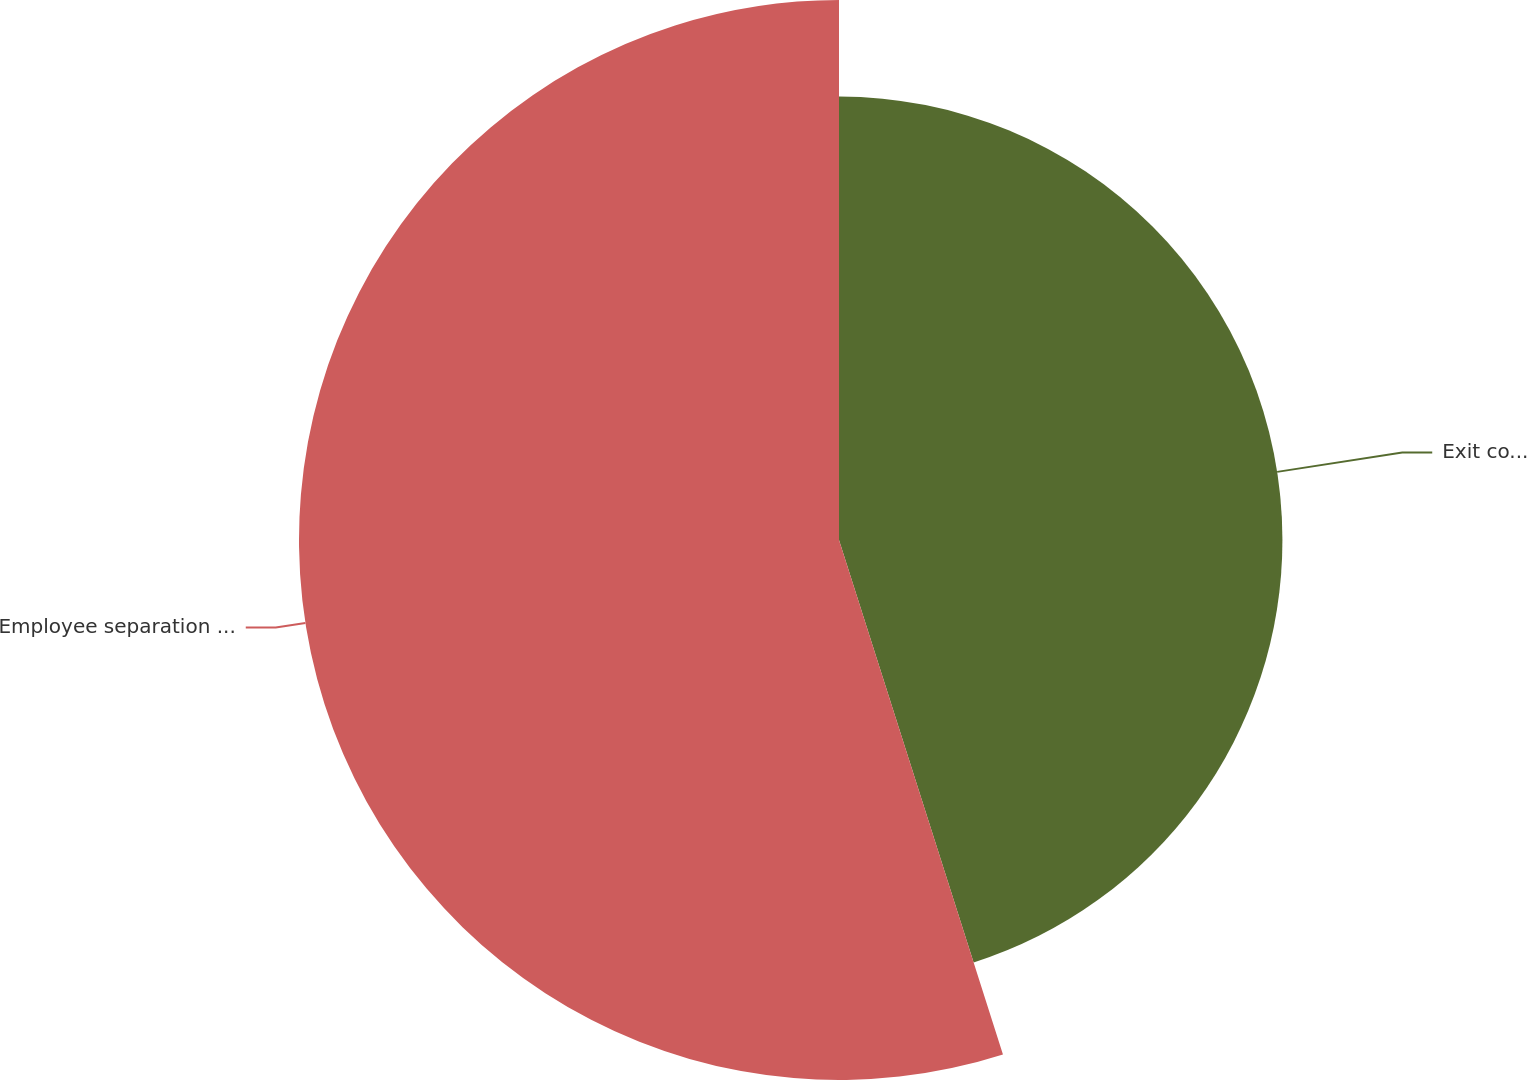Convert chart. <chart><loc_0><loc_0><loc_500><loc_500><pie_chart><fcel>Exit costsÌlease terminations<fcel>Employee separation costs<nl><fcel>45.09%<fcel>54.91%<nl></chart> 